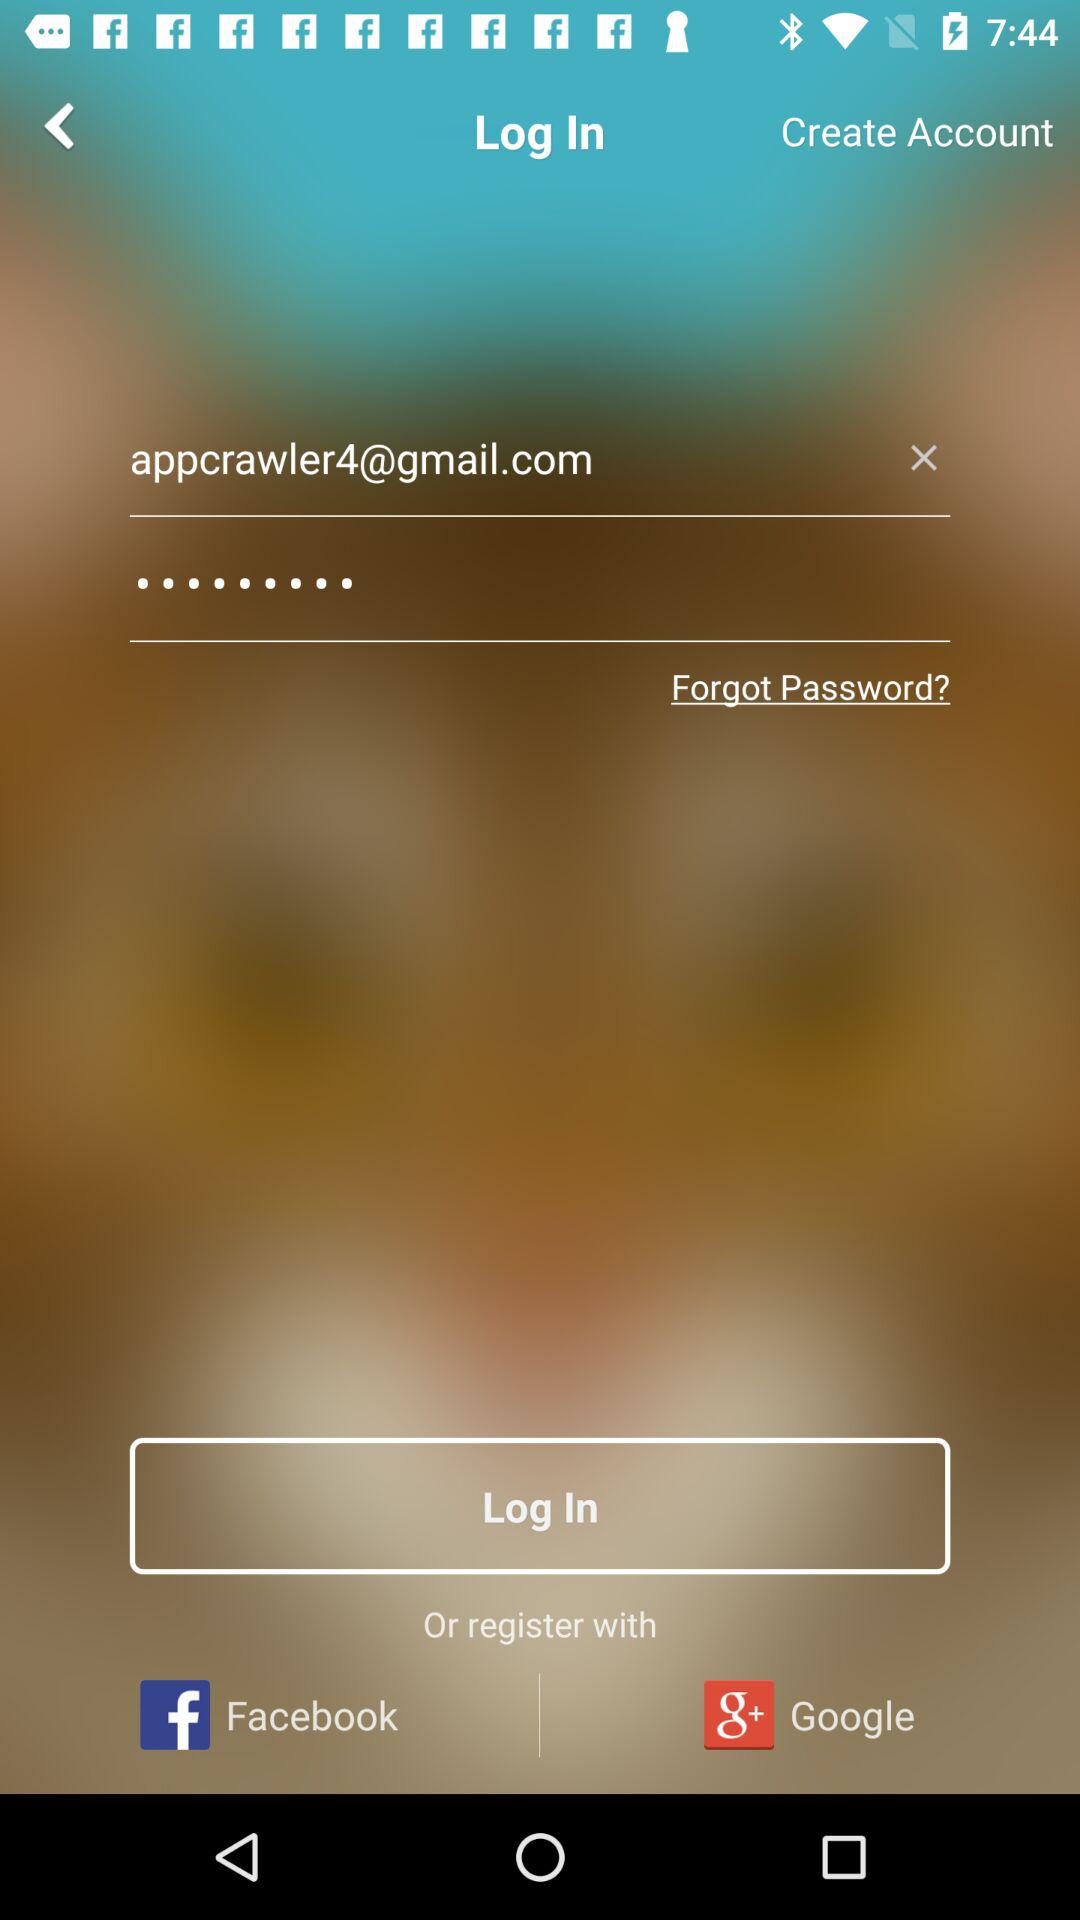How many text input fields are there on this screen?
Answer the question using a single word or phrase. 2 